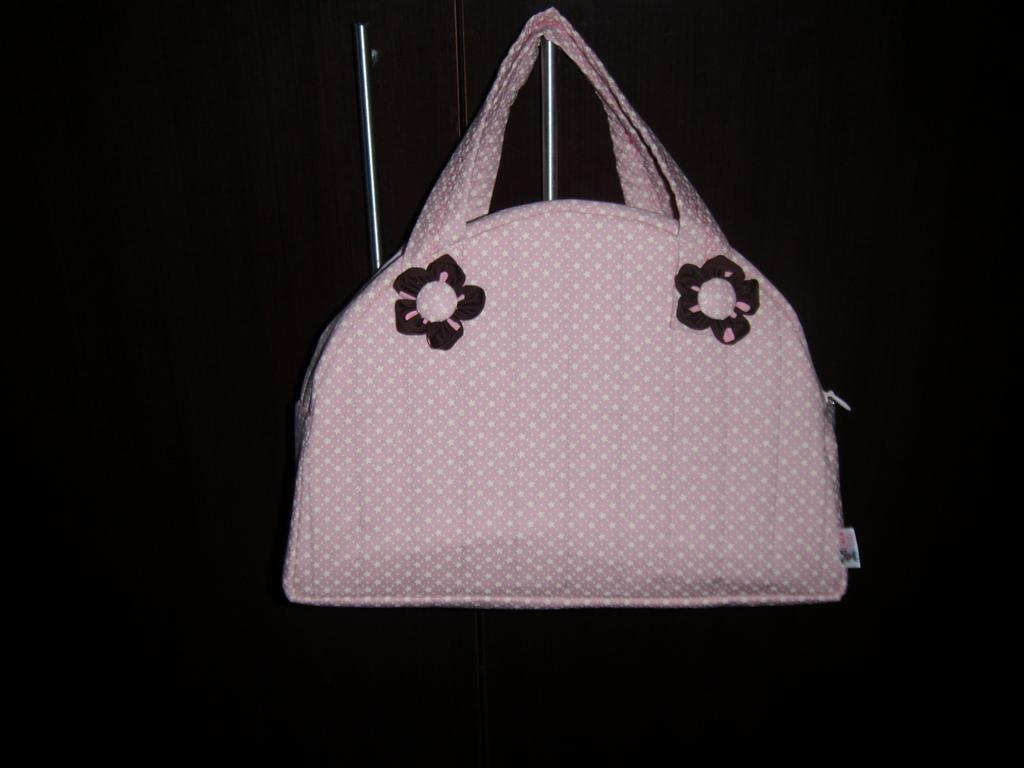What object is visible in the image? There is a handbag in the image. How is the handbag positioned in the image? The handbag is hung on something. What type of shoes are being discussed by the committee at the table in the image? There is no mention of a committee, table, or shoes in the image; it only features a handbag. 